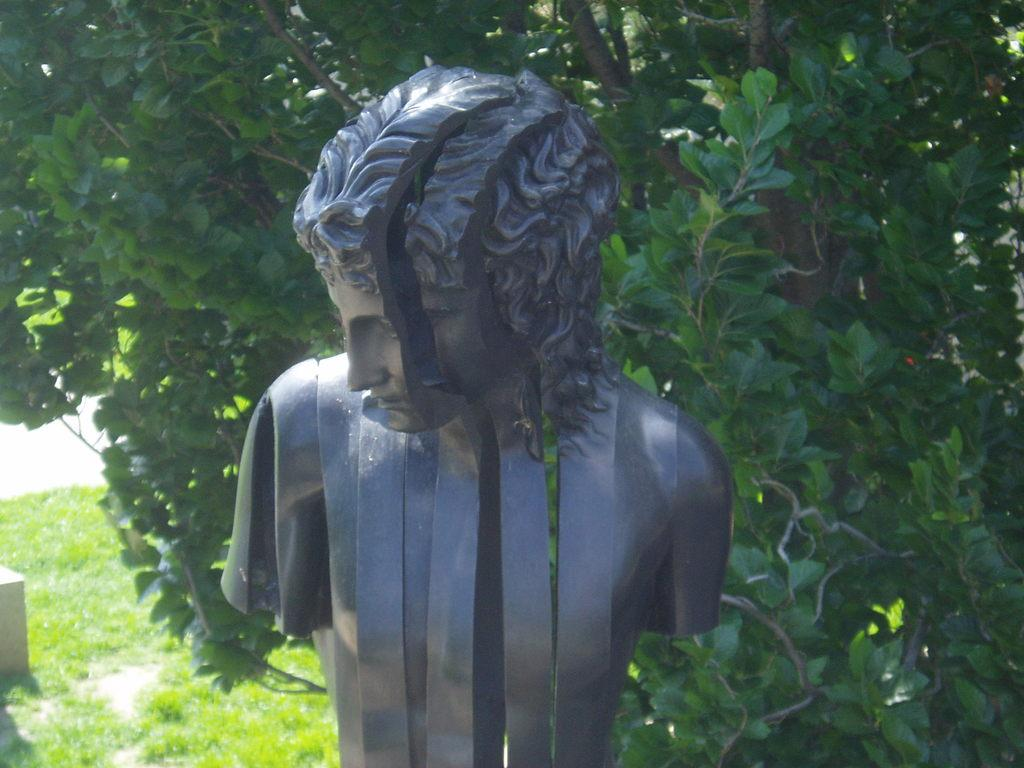What is the main subject of the image? There is a statue in the image. What is the color of the statue? The statue is black in color. What can be seen behind the statue? There is a tree behind the statue. What type of lace is draped over the statue in the image? There is no lace present in the image; the statue is simply standing in front of a tree. 